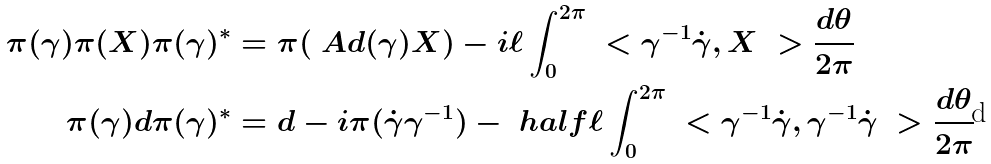<formula> <loc_0><loc_0><loc_500><loc_500>\pi ( \gamma ) \pi ( X ) \pi ( \gamma ) ^ { * } & = \pi ( \ A d ( \gamma ) X ) - i \ell \int _ { 0 } ^ { 2 \pi } \ < \gamma ^ { - 1 } \dot { \gamma } , X \ > \frac { d \theta } { 2 \pi } \\ \pi ( \gamma ) d \pi ( \gamma ) ^ { * } & = d - i \pi ( \dot { \gamma } \gamma ^ { - 1 } ) - \ h a l f { \ell } \int _ { 0 } ^ { 2 \pi } \ < \gamma ^ { - 1 } \dot { \gamma } , \gamma ^ { - 1 } \dot { \gamma } \ > \frac { d \theta } { 2 \pi }</formula> 